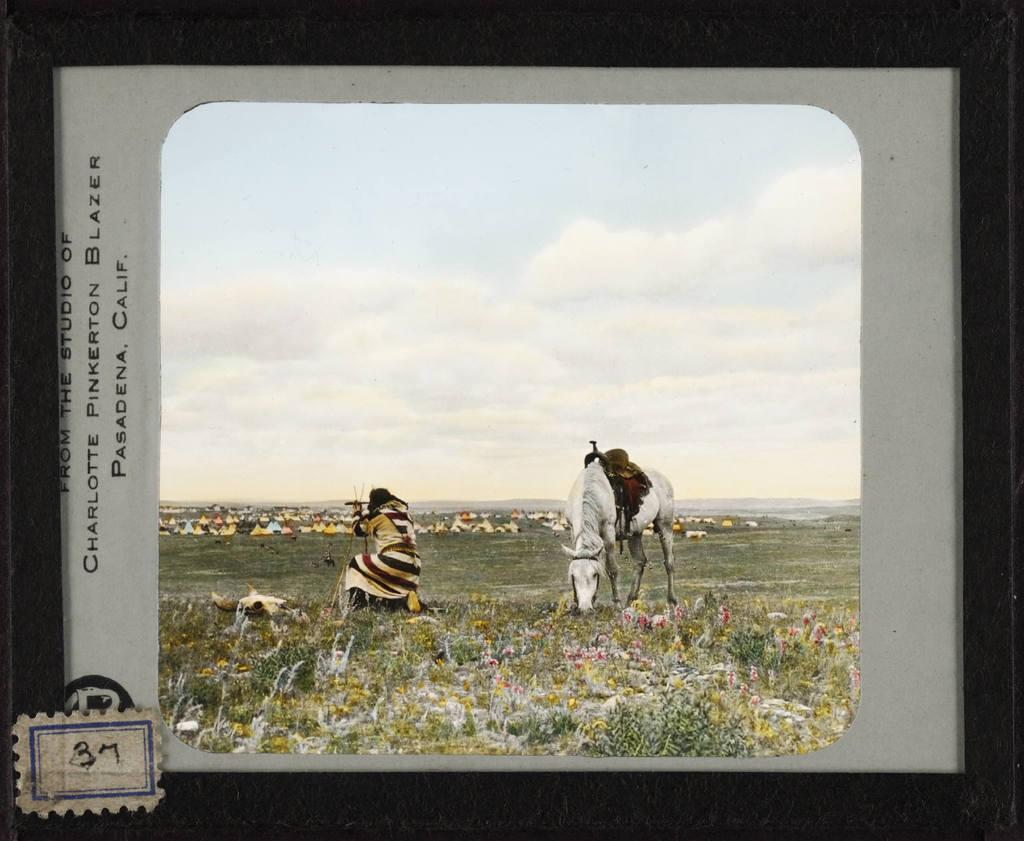Provide a one-sentence caption for the provided image. A painting of a native american man next to a horse that is labeled Pasadena Calif. 